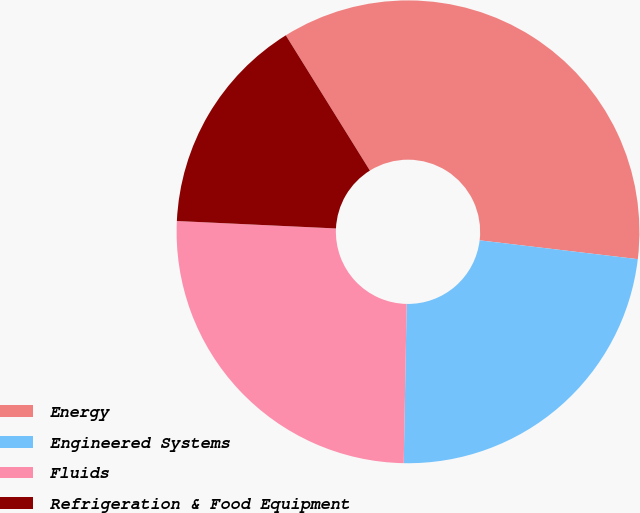<chart> <loc_0><loc_0><loc_500><loc_500><pie_chart><fcel>Energy<fcel>Engineered Systems<fcel>Fluids<fcel>Refrigeration & Food Equipment<nl><fcel>35.74%<fcel>23.41%<fcel>25.45%<fcel>15.4%<nl></chart> 